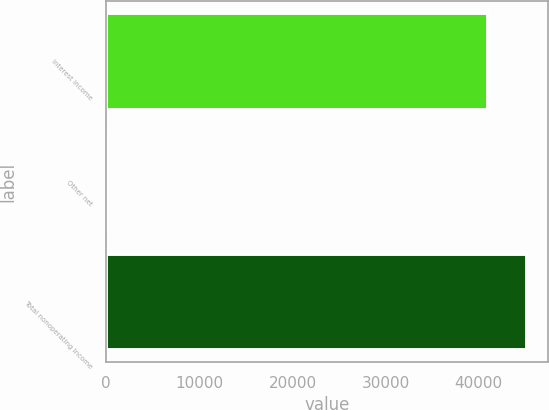<chart> <loc_0><loc_0><loc_500><loc_500><bar_chart><fcel>Interest income<fcel>Other net<fcel>Total nonoperating income<nl><fcel>41041<fcel>36<fcel>45145.1<nl></chart> 